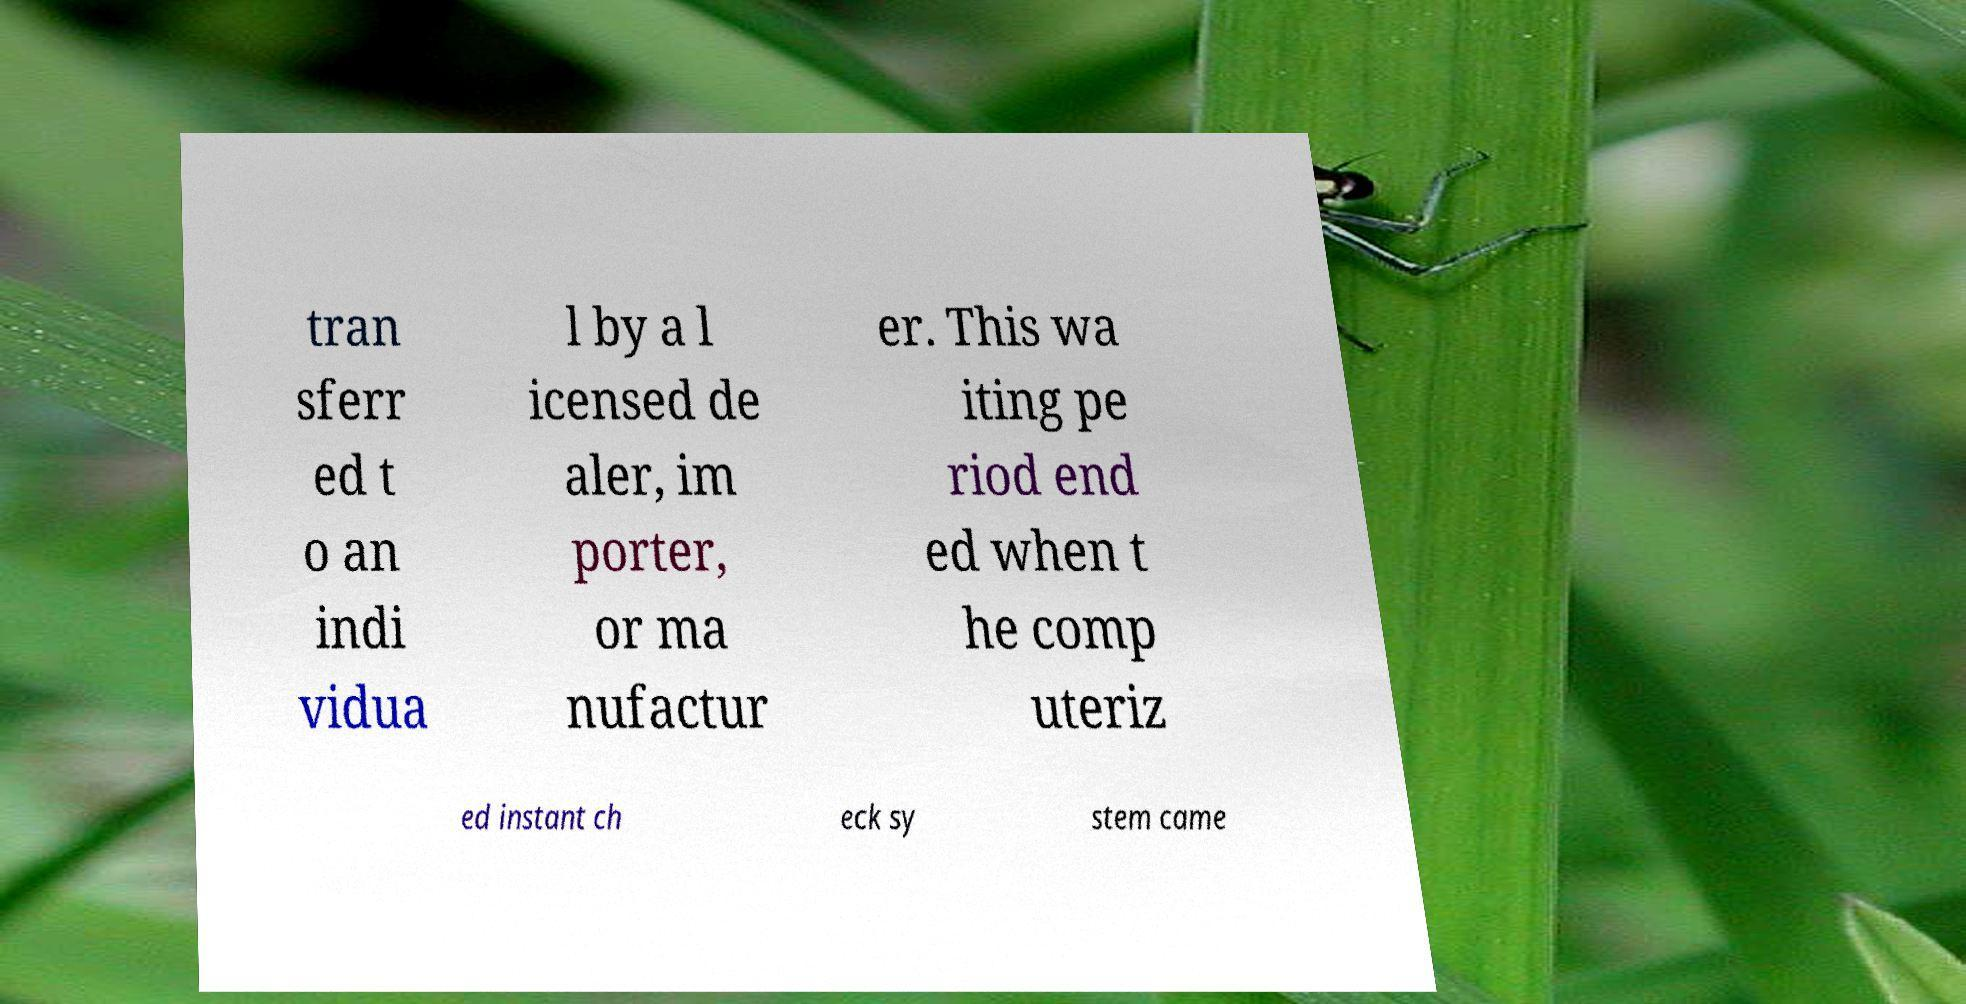Can you accurately transcribe the text from the provided image for me? tran sferr ed t o an indi vidua l by a l icensed de aler, im porter, or ma nufactur er. This wa iting pe riod end ed when t he comp uteriz ed instant ch eck sy stem came 